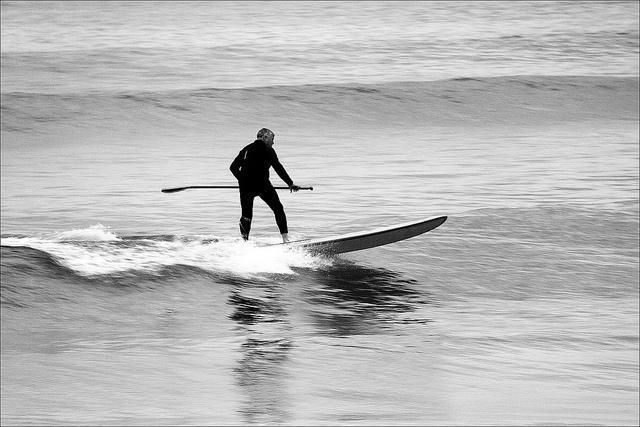How many train cars are on the right of the man ?
Give a very brief answer. 0. 